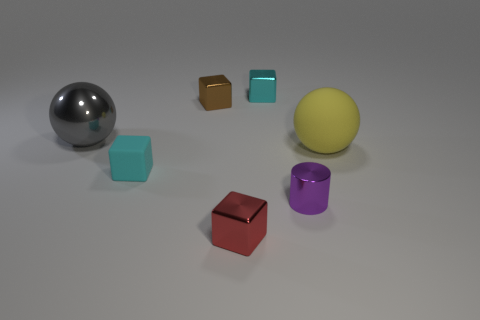Is there any other thing that has the same shape as the tiny purple metallic object?
Make the answer very short. No. There is another matte thing that is the same shape as the small brown object; what color is it?
Your response must be concise. Cyan. Do the tiny rubber cube behind the purple shiny thing and the block right of the tiny red shiny object have the same color?
Give a very brief answer. Yes. Is the number of spheres that are to the left of the small matte cube greater than the number of big blue metallic objects?
Your response must be concise. Yes. What number of other objects are the same size as the gray ball?
Give a very brief answer. 1. What number of cubes are both in front of the big metal thing and behind the large gray object?
Keep it short and to the point. 0. Do the tiny cyan block left of the tiny brown shiny thing and the yellow sphere have the same material?
Your answer should be compact. Yes. What is the shape of the tiny cyan object in front of the small cyan block behind the small cyan object in front of the large gray metallic object?
Offer a very short reply. Cube. Are there the same number of big rubber balls that are in front of the matte cube and rubber things that are right of the cyan metallic thing?
Your answer should be compact. No. The other sphere that is the same size as the yellow matte sphere is what color?
Provide a short and direct response. Gray. 